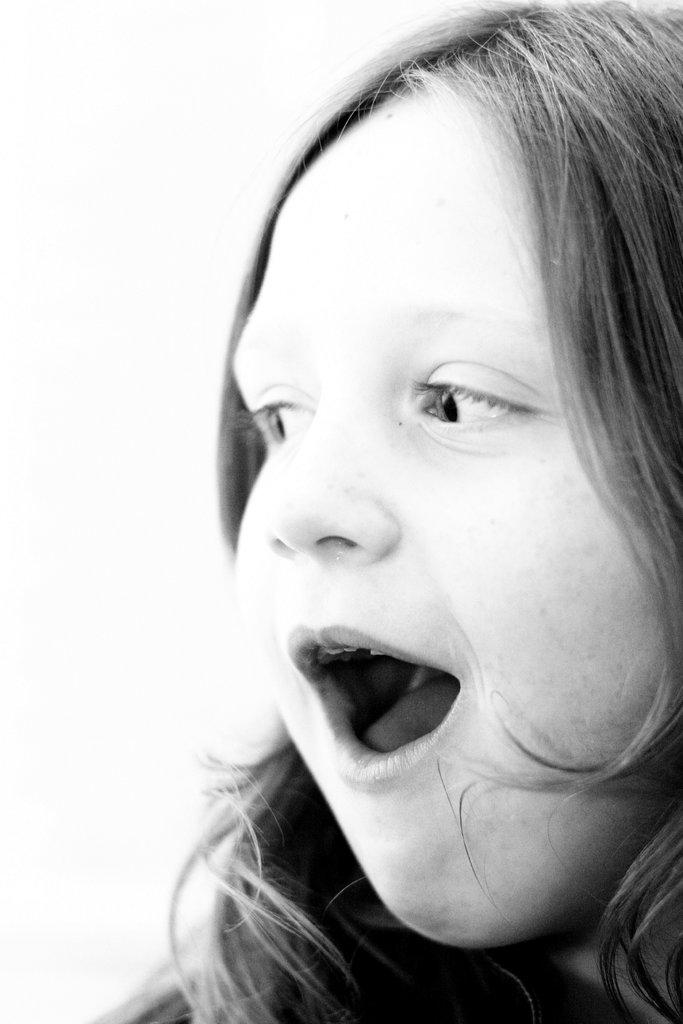What is the main subject of the image? There is a girl in the image. What type of fish can be seen swimming in the jeans in the image? There is no fish or jeans present in the image; it features a girl. 